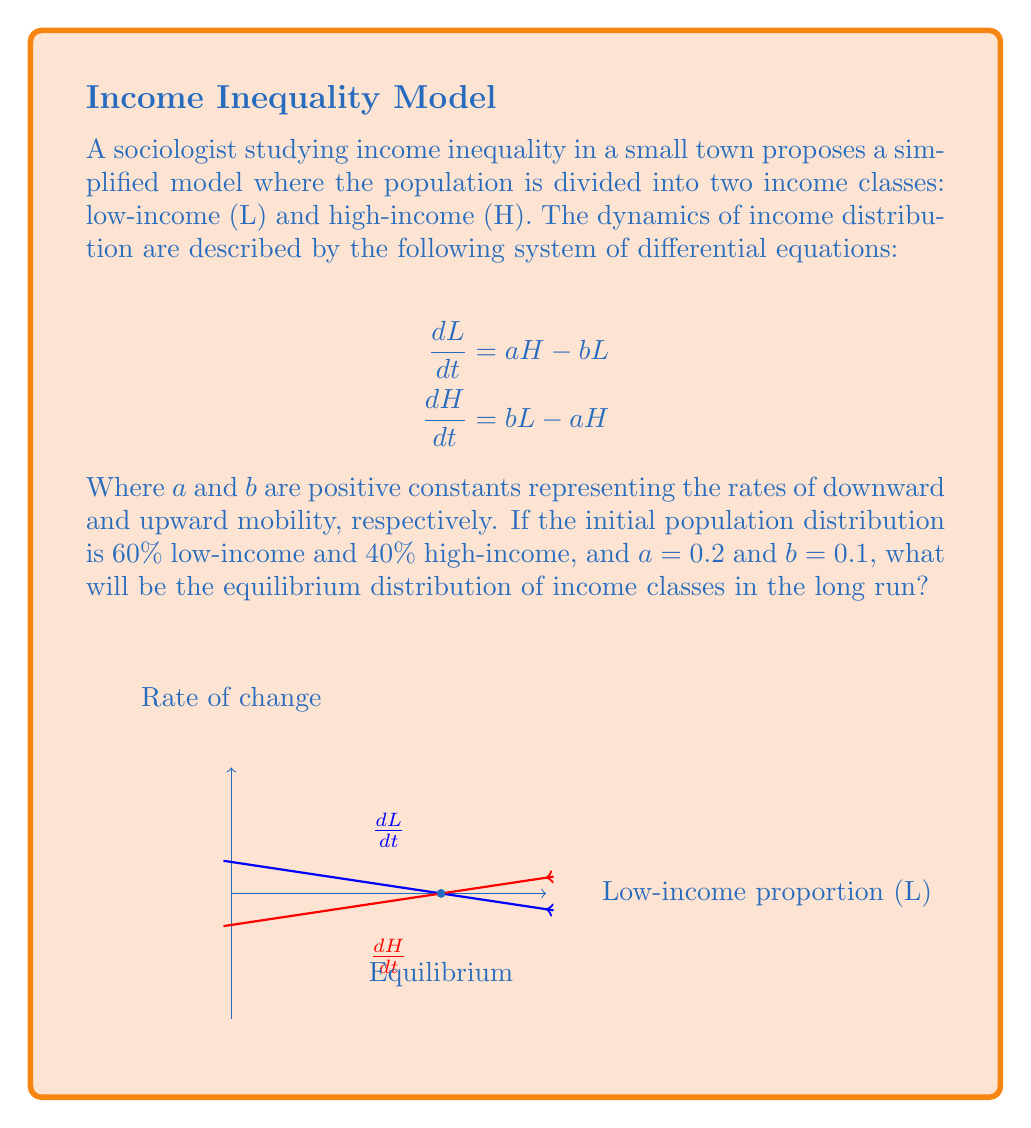Can you answer this question? To solve this problem, we'll follow these steps:

1) First, we need to find the equilibrium point. At equilibrium, the rates of change for both classes will be zero:

   $$\frac{dL}{dt} = \frac{dH}{dt} = 0$$

2) We can use either equation to solve for the equilibrium. Let's use the first one:

   $$aH - bL = 0$$

3) We also know that $L + H = 1$ (total population is normalized to 1). Substituting $H = 1 - L$:

   $$a(1-L) - bL = 0$$

4) Solving for L:

   $$a - aL - bL = 0$$
   $$a = (a+b)L$$
   $$L = \frac{a}{a+b}$$

5) Substituting the given values $a = 0.2$ and $b = 0.1$:

   $$L = \frac{0.2}{0.2 + 0.1} = \frac{2}{3} \approx 0.667$$

6) Since $L + H = 1$, we can find H:

   $$H = 1 - L = 1 - \frac{2}{3} = \frac{1}{3} \approx 0.333$$

Therefore, the equilibrium distribution will be approximately 66.7% low-income and 33.3% high-income.

Note: The initial distribution (60% L, 40% H) is close to but not exactly at the equilibrium. Over time, the system will converge to this equilibrium state.
Answer: 66.7% low-income, 33.3% high-income 